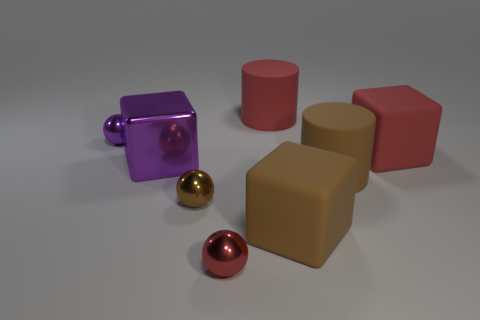How could these objects be used in a practical setting? These objects could serve various practical purposes depending on their material and scale. For example, the cubes and cylinders could be containers, furniture pieces, or architectural models if they are large, or game pieces or educational tools for shape recognition if they are small. 